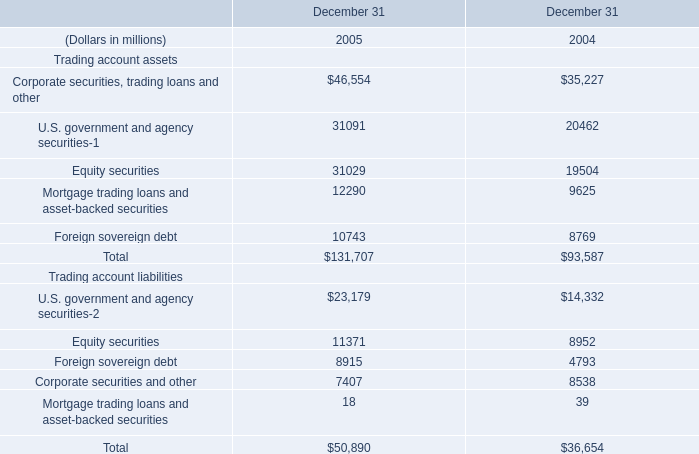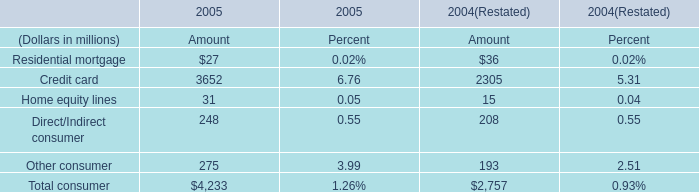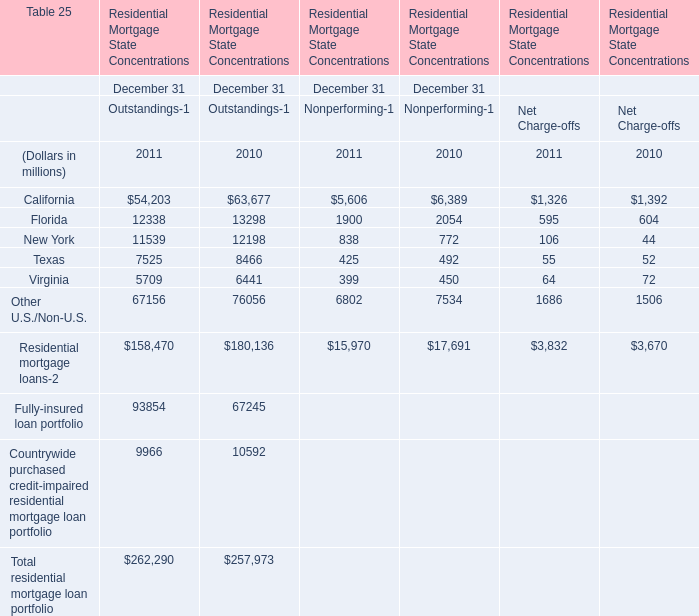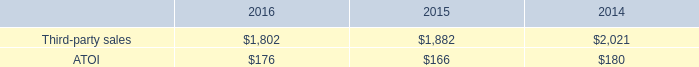In the year with the most Residential mortgage loans, what is the growth rate of Total residential mortgage loan portfolio? 
Computations: ((262290 - 257973) / 257973)
Answer: 0.01673. 